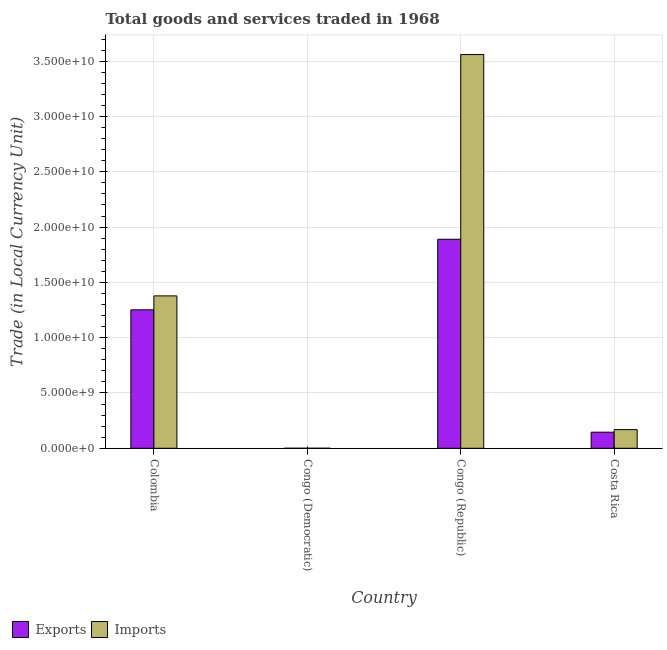Are the number of bars per tick equal to the number of legend labels?
Provide a short and direct response. Yes. How many bars are there on the 2nd tick from the left?
Offer a terse response. 2. What is the label of the 2nd group of bars from the left?
Offer a very short reply. Congo (Democratic). In how many cases, is the number of bars for a given country not equal to the number of legend labels?
Your answer should be very brief. 0. What is the imports of goods and services in Costa Rica?
Provide a succinct answer. 1.69e+09. Across all countries, what is the maximum imports of goods and services?
Keep it short and to the point. 3.56e+1. Across all countries, what is the minimum export of goods and services?
Provide a short and direct response. 0. In which country was the export of goods and services maximum?
Keep it short and to the point. Congo (Republic). In which country was the export of goods and services minimum?
Ensure brevity in your answer.  Congo (Democratic). What is the total imports of goods and services in the graph?
Offer a very short reply. 5.11e+1. What is the difference between the export of goods and services in Congo (Republic) and that in Costa Rica?
Provide a short and direct response. 1.74e+1. What is the difference between the imports of goods and services in Congo (Republic) and the export of goods and services in Congo (Democratic)?
Your response must be concise. 3.56e+1. What is the average imports of goods and services per country?
Offer a terse response. 1.28e+1. What is the difference between the imports of goods and services and export of goods and services in Costa Rica?
Give a very brief answer. 2.31e+08. What is the ratio of the imports of goods and services in Colombia to that in Congo (Republic)?
Give a very brief answer. 0.39. Is the imports of goods and services in Congo (Republic) less than that in Costa Rica?
Your answer should be compact. No. Is the difference between the export of goods and services in Congo (Democratic) and Congo (Republic) greater than the difference between the imports of goods and services in Congo (Democratic) and Congo (Republic)?
Your answer should be compact. Yes. What is the difference between the highest and the second highest export of goods and services?
Offer a very short reply. 6.38e+09. What is the difference between the highest and the lowest imports of goods and services?
Offer a very short reply. 3.56e+1. Is the sum of the export of goods and services in Colombia and Congo (Republic) greater than the maximum imports of goods and services across all countries?
Give a very brief answer. No. What does the 2nd bar from the left in Congo (Democratic) represents?
Your answer should be very brief. Imports. What does the 2nd bar from the right in Costa Rica represents?
Your answer should be very brief. Exports. What is the difference between two consecutive major ticks on the Y-axis?
Your answer should be compact. 5.00e+09. How are the legend labels stacked?
Provide a succinct answer. Horizontal. What is the title of the graph?
Ensure brevity in your answer.  Total goods and services traded in 1968. What is the label or title of the Y-axis?
Make the answer very short. Trade (in Local Currency Unit). What is the Trade (in Local Currency Unit) of Exports in Colombia?
Offer a terse response. 1.25e+1. What is the Trade (in Local Currency Unit) in Imports in Colombia?
Offer a very short reply. 1.38e+1. What is the Trade (in Local Currency Unit) in Exports in Congo (Democratic)?
Your answer should be compact. 0. What is the Trade (in Local Currency Unit) of Imports in Congo (Democratic)?
Keep it short and to the point. 0. What is the Trade (in Local Currency Unit) in Exports in Congo (Republic)?
Your response must be concise. 1.89e+1. What is the Trade (in Local Currency Unit) in Imports in Congo (Republic)?
Offer a terse response. 3.56e+1. What is the Trade (in Local Currency Unit) in Exports in Costa Rica?
Keep it short and to the point. 1.46e+09. What is the Trade (in Local Currency Unit) of Imports in Costa Rica?
Provide a short and direct response. 1.69e+09. Across all countries, what is the maximum Trade (in Local Currency Unit) in Exports?
Your answer should be very brief. 1.89e+1. Across all countries, what is the maximum Trade (in Local Currency Unit) of Imports?
Give a very brief answer. 3.56e+1. Across all countries, what is the minimum Trade (in Local Currency Unit) of Exports?
Give a very brief answer. 0. Across all countries, what is the minimum Trade (in Local Currency Unit) of Imports?
Provide a short and direct response. 0. What is the total Trade (in Local Currency Unit) of Exports in the graph?
Offer a very short reply. 3.29e+1. What is the total Trade (in Local Currency Unit) in Imports in the graph?
Offer a very short reply. 5.11e+1. What is the difference between the Trade (in Local Currency Unit) of Exports in Colombia and that in Congo (Democratic)?
Your response must be concise. 1.25e+1. What is the difference between the Trade (in Local Currency Unit) of Imports in Colombia and that in Congo (Democratic)?
Give a very brief answer. 1.38e+1. What is the difference between the Trade (in Local Currency Unit) of Exports in Colombia and that in Congo (Republic)?
Your response must be concise. -6.38e+09. What is the difference between the Trade (in Local Currency Unit) in Imports in Colombia and that in Congo (Republic)?
Offer a terse response. -2.18e+1. What is the difference between the Trade (in Local Currency Unit) of Exports in Colombia and that in Costa Rica?
Ensure brevity in your answer.  1.11e+1. What is the difference between the Trade (in Local Currency Unit) in Imports in Colombia and that in Costa Rica?
Provide a short and direct response. 1.21e+1. What is the difference between the Trade (in Local Currency Unit) in Exports in Congo (Democratic) and that in Congo (Republic)?
Ensure brevity in your answer.  -1.89e+1. What is the difference between the Trade (in Local Currency Unit) of Imports in Congo (Democratic) and that in Congo (Republic)?
Your answer should be compact. -3.56e+1. What is the difference between the Trade (in Local Currency Unit) in Exports in Congo (Democratic) and that in Costa Rica?
Your answer should be very brief. -1.46e+09. What is the difference between the Trade (in Local Currency Unit) of Imports in Congo (Democratic) and that in Costa Rica?
Provide a succinct answer. -1.69e+09. What is the difference between the Trade (in Local Currency Unit) of Exports in Congo (Republic) and that in Costa Rica?
Provide a short and direct response. 1.74e+1. What is the difference between the Trade (in Local Currency Unit) of Imports in Congo (Republic) and that in Costa Rica?
Offer a terse response. 3.39e+1. What is the difference between the Trade (in Local Currency Unit) of Exports in Colombia and the Trade (in Local Currency Unit) of Imports in Congo (Democratic)?
Ensure brevity in your answer.  1.25e+1. What is the difference between the Trade (in Local Currency Unit) in Exports in Colombia and the Trade (in Local Currency Unit) in Imports in Congo (Republic)?
Your answer should be very brief. -2.31e+1. What is the difference between the Trade (in Local Currency Unit) of Exports in Colombia and the Trade (in Local Currency Unit) of Imports in Costa Rica?
Your response must be concise. 1.08e+1. What is the difference between the Trade (in Local Currency Unit) in Exports in Congo (Democratic) and the Trade (in Local Currency Unit) in Imports in Congo (Republic)?
Your response must be concise. -3.56e+1. What is the difference between the Trade (in Local Currency Unit) of Exports in Congo (Democratic) and the Trade (in Local Currency Unit) of Imports in Costa Rica?
Offer a very short reply. -1.69e+09. What is the difference between the Trade (in Local Currency Unit) in Exports in Congo (Republic) and the Trade (in Local Currency Unit) in Imports in Costa Rica?
Make the answer very short. 1.72e+1. What is the average Trade (in Local Currency Unit) in Exports per country?
Offer a very short reply. 8.22e+09. What is the average Trade (in Local Currency Unit) in Imports per country?
Keep it short and to the point. 1.28e+1. What is the difference between the Trade (in Local Currency Unit) of Exports and Trade (in Local Currency Unit) of Imports in Colombia?
Offer a very short reply. -1.26e+09. What is the difference between the Trade (in Local Currency Unit) in Exports and Trade (in Local Currency Unit) in Imports in Congo (Democratic)?
Ensure brevity in your answer.  -0. What is the difference between the Trade (in Local Currency Unit) in Exports and Trade (in Local Currency Unit) in Imports in Congo (Republic)?
Your answer should be compact. -1.67e+1. What is the difference between the Trade (in Local Currency Unit) of Exports and Trade (in Local Currency Unit) of Imports in Costa Rica?
Give a very brief answer. -2.31e+08. What is the ratio of the Trade (in Local Currency Unit) of Exports in Colombia to that in Congo (Democratic)?
Your answer should be compact. 1.32e+13. What is the ratio of the Trade (in Local Currency Unit) of Imports in Colombia to that in Congo (Democratic)?
Make the answer very short. 1.38e+13. What is the ratio of the Trade (in Local Currency Unit) of Exports in Colombia to that in Congo (Republic)?
Provide a short and direct response. 0.66. What is the ratio of the Trade (in Local Currency Unit) of Imports in Colombia to that in Congo (Republic)?
Your response must be concise. 0.39. What is the ratio of the Trade (in Local Currency Unit) of Exports in Colombia to that in Costa Rica?
Provide a succinct answer. 8.6. What is the ratio of the Trade (in Local Currency Unit) of Imports in Colombia to that in Costa Rica?
Provide a succinct answer. 8.17. What is the ratio of the Trade (in Local Currency Unit) in Exports in Congo (Republic) to that in Costa Rica?
Ensure brevity in your answer.  12.98. What is the ratio of the Trade (in Local Currency Unit) of Imports in Congo (Republic) to that in Costa Rica?
Offer a very short reply. 21.1. What is the difference between the highest and the second highest Trade (in Local Currency Unit) of Exports?
Make the answer very short. 6.38e+09. What is the difference between the highest and the second highest Trade (in Local Currency Unit) of Imports?
Give a very brief answer. 2.18e+1. What is the difference between the highest and the lowest Trade (in Local Currency Unit) in Exports?
Offer a terse response. 1.89e+1. What is the difference between the highest and the lowest Trade (in Local Currency Unit) in Imports?
Your response must be concise. 3.56e+1. 